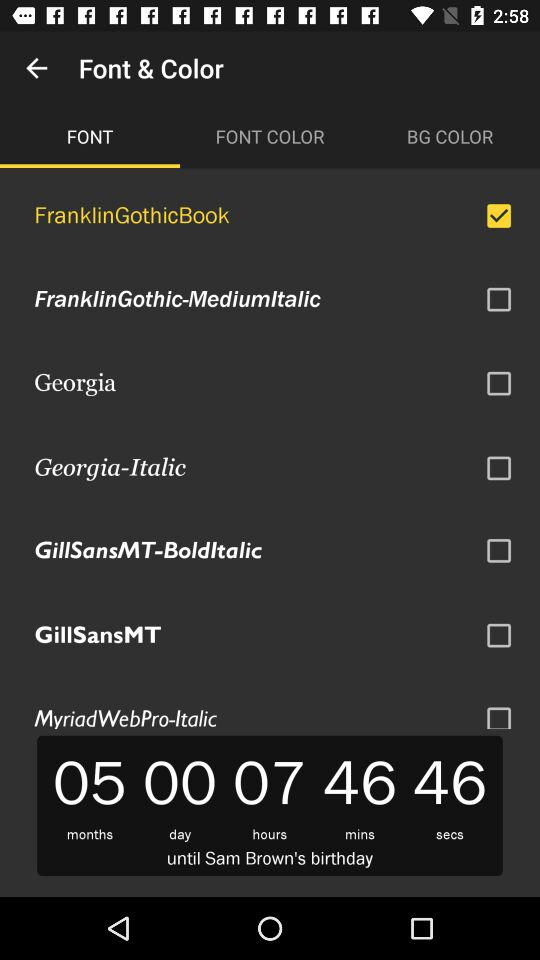How much time is left until Sam Brown's birthday? The time left until Sam Brown's birthday is 5 months 0 days 7 hours 46 minutes 46 seconds. 